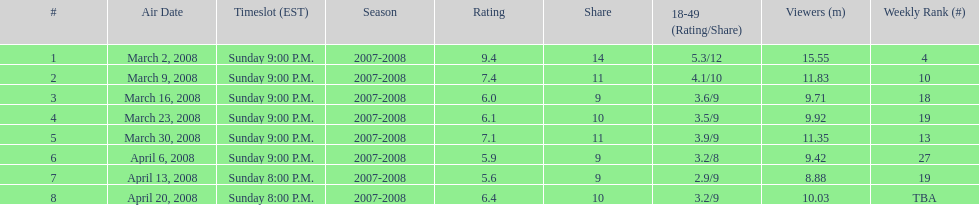How many programs had over 10 million spectators? 4. 